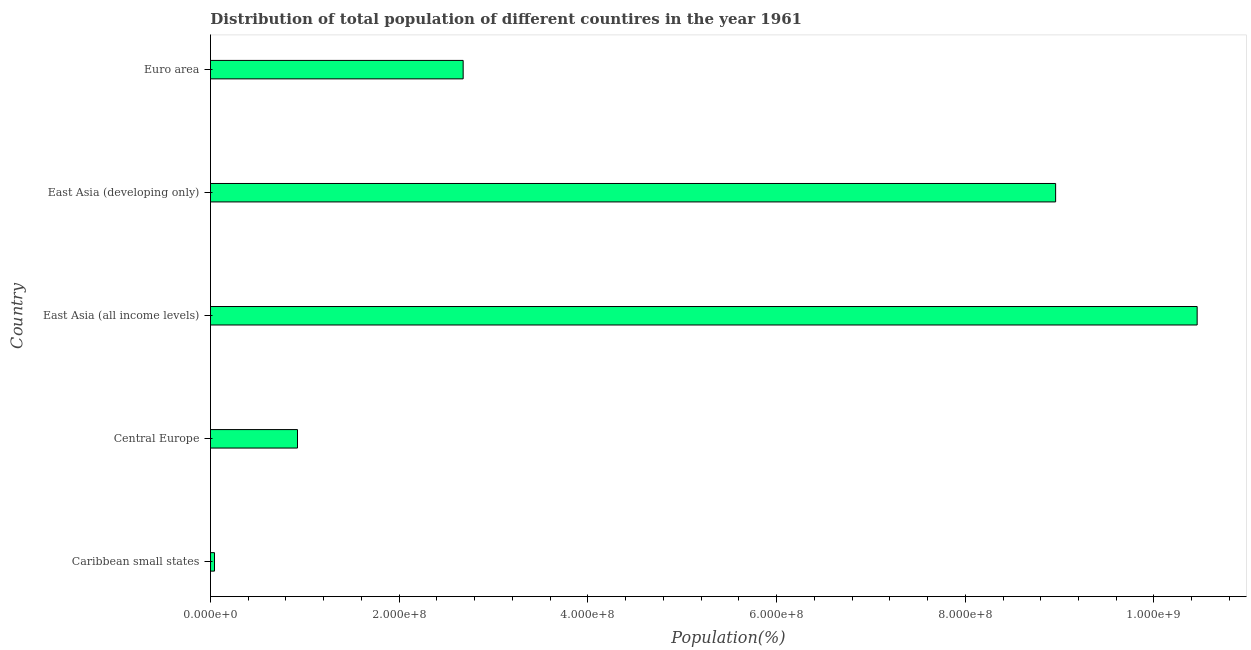Does the graph contain grids?
Provide a short and direct response. No. What is the title of the graph?
Offer a very short reply. Distribution of total population of different countires in the year 1961. What is the label or title of the X-axis?
Ensure brevity in your answer.  Population(%). What is the label or title of the Y-axis?
Offer a very short reply. Country. What is the population in Euro area?
Give a very brief answer. 2.68e+08. Across all countries, what is the maximum population?
Give a very brief answer. 1.05e+09. Across all countries, what is the minimum population?
Ensure brevity in your answer.  4.27e+06. In which country was the population maximum?
Offer a very short reply. East Asia (all income levels). In which country was the population minimum?
Provide a succinct answer. Caribbean small states. What is the sum of the population?
Offer a terse response. 2.31e+09. What is the difference between the population in Central Europe and Euro area?
Ensure brevity in your answer.  -1.76e+08. What is the average population per country?
Keep it short and to the point. 4.61e+08. What is the median population?
Make the answer very short. 2.68e+08. What is the ratio of the population in East Asia (all income levels) to that in East Asia (developing only)?
Your answer should be very brief. 1.17. Is the population in Caribbean small states less than that in East Asia (developing only)?
Ensure brevity in your answer.  Yes. Is the difference between the population in East Asia (all income levels) and Euro area greater than the difference between any two countries?
Your answer should be compact. No. What is the difference between the highest and the second highest population?
Your answer should be compact. 1.50e+08. Is the sum of the population in East Asia (developing only) and Euro area greater than the maximum population across all countries?
Provide a short and direct response. Yes. What is the difference between the highest and the lowest population?
Make the answer very short. 1.04e+09. How many bars are there?
Give a very brief answer. 5. Are all the bars in the graph horizontal?
Give a very brief answer. Yes. How many countries are there in the graph?
Ensure brevity in your answer.  5. What is the difference between two consecutive major ticks on the X-axis?
Your answer should be compact. 2.00e+08. Are the values on the major ticks of X-axis written in scientific E-notation?
Make the answer very short. Yes. What is the Population(%) in Caribbean small states?
Your answer should be compact. 4.27e+06. What is the Population(%) in Central Europe?
Offer a terse response. 9.22e+07. What is the Population(%) in East Asia (all income levels)?
Make the answer very short. 1.05e+09. What is the Population(%) in East Asia (developing only)?
Offer a terse response. 8.96e+08. What is the Population(%) in Euro area?
Make the answer very short. 2.68e+08. What is the difference between the Population(%) in Caribbean small states and Central Europe?
Your answer should be compact. -8.80e+07. What is the difference between the Population(%) in Caribbean small states and East Asia (all income levels)?
Ensure brevity in your answer.  -1.04e+09. What is the difference between the Population(%) in Caribbean small states and East Asia (developing only)?
Offer a very short reply. -8.92e+08. What is the difference between the Population(%) in Caribbean small states and Euro area?
Make the answer very short. -2.64e+08. What is the difference between the Population(%) in Central Europe and East Asia (all income levels)?
Give a very brief answer. -9.54e+08. What is the difference between the Population(%) in Central Europe and East Asia (developing only)?
Your answer should be very brief. -8.04e+08. What is the difference between the Population(%) in Central Europe and Euro area?
Make the answer very short. -1.76e+08. What is the difference between the Population(%) in East Asia (all income levels) and East Asia (developing only)?
Provide a short and direct response. 1.50e+08. What is the difference between the Population(%) in East Asia (all income levels) and Euro area?
Your answer should be compact. 7.78e+08. What is the difference between the Population(%) in East Asia (developing only) and Euro area?
Your response must be concise. 6.28e+08. What is the ratio of the Population(%) in Caribbean small states to that in Central Europe?
Your answer should be compact. 0.05. What is the ratio of the Population(%) in Caribbean small states to that in East Asia (all income levels)?
Ensure brevity in your answer.  0. What is the ratio of the Population(%) in Caribbean small states to that in East Asia (developing only)?
Give a very brief answer. 0.01. What is the ratio of the Population(%) in Caribbean small states to that in Euro area?
Provide a short and direct response. 0.02. What is the ratio of the Population(%) in Central Europe to that in East Asia (all income levels)?
Keep it short and to the point. 0.09. What is the ratio of the Population(%) in Central Europe to that in East Asia (developing only)?
Your response must be concise. 0.1. What is the ratio of the Population(%) in Central Europe to that in Euro area?
Your response must be concise. 0.34. What is the ratio of the Population(%) in East Asia (all income levels) to that in East Asia (developing only)?
Provide a succinct answer. 1.17. What is the ratio of the Population(%) in East Asia (all income levels) to that in Euro area?
Ensure brevity in your answer.  3.9. What is the ratio of the Population(%) in East Asia (developing only) to that in Euro area?
Offer a very short reply. 3.35. 